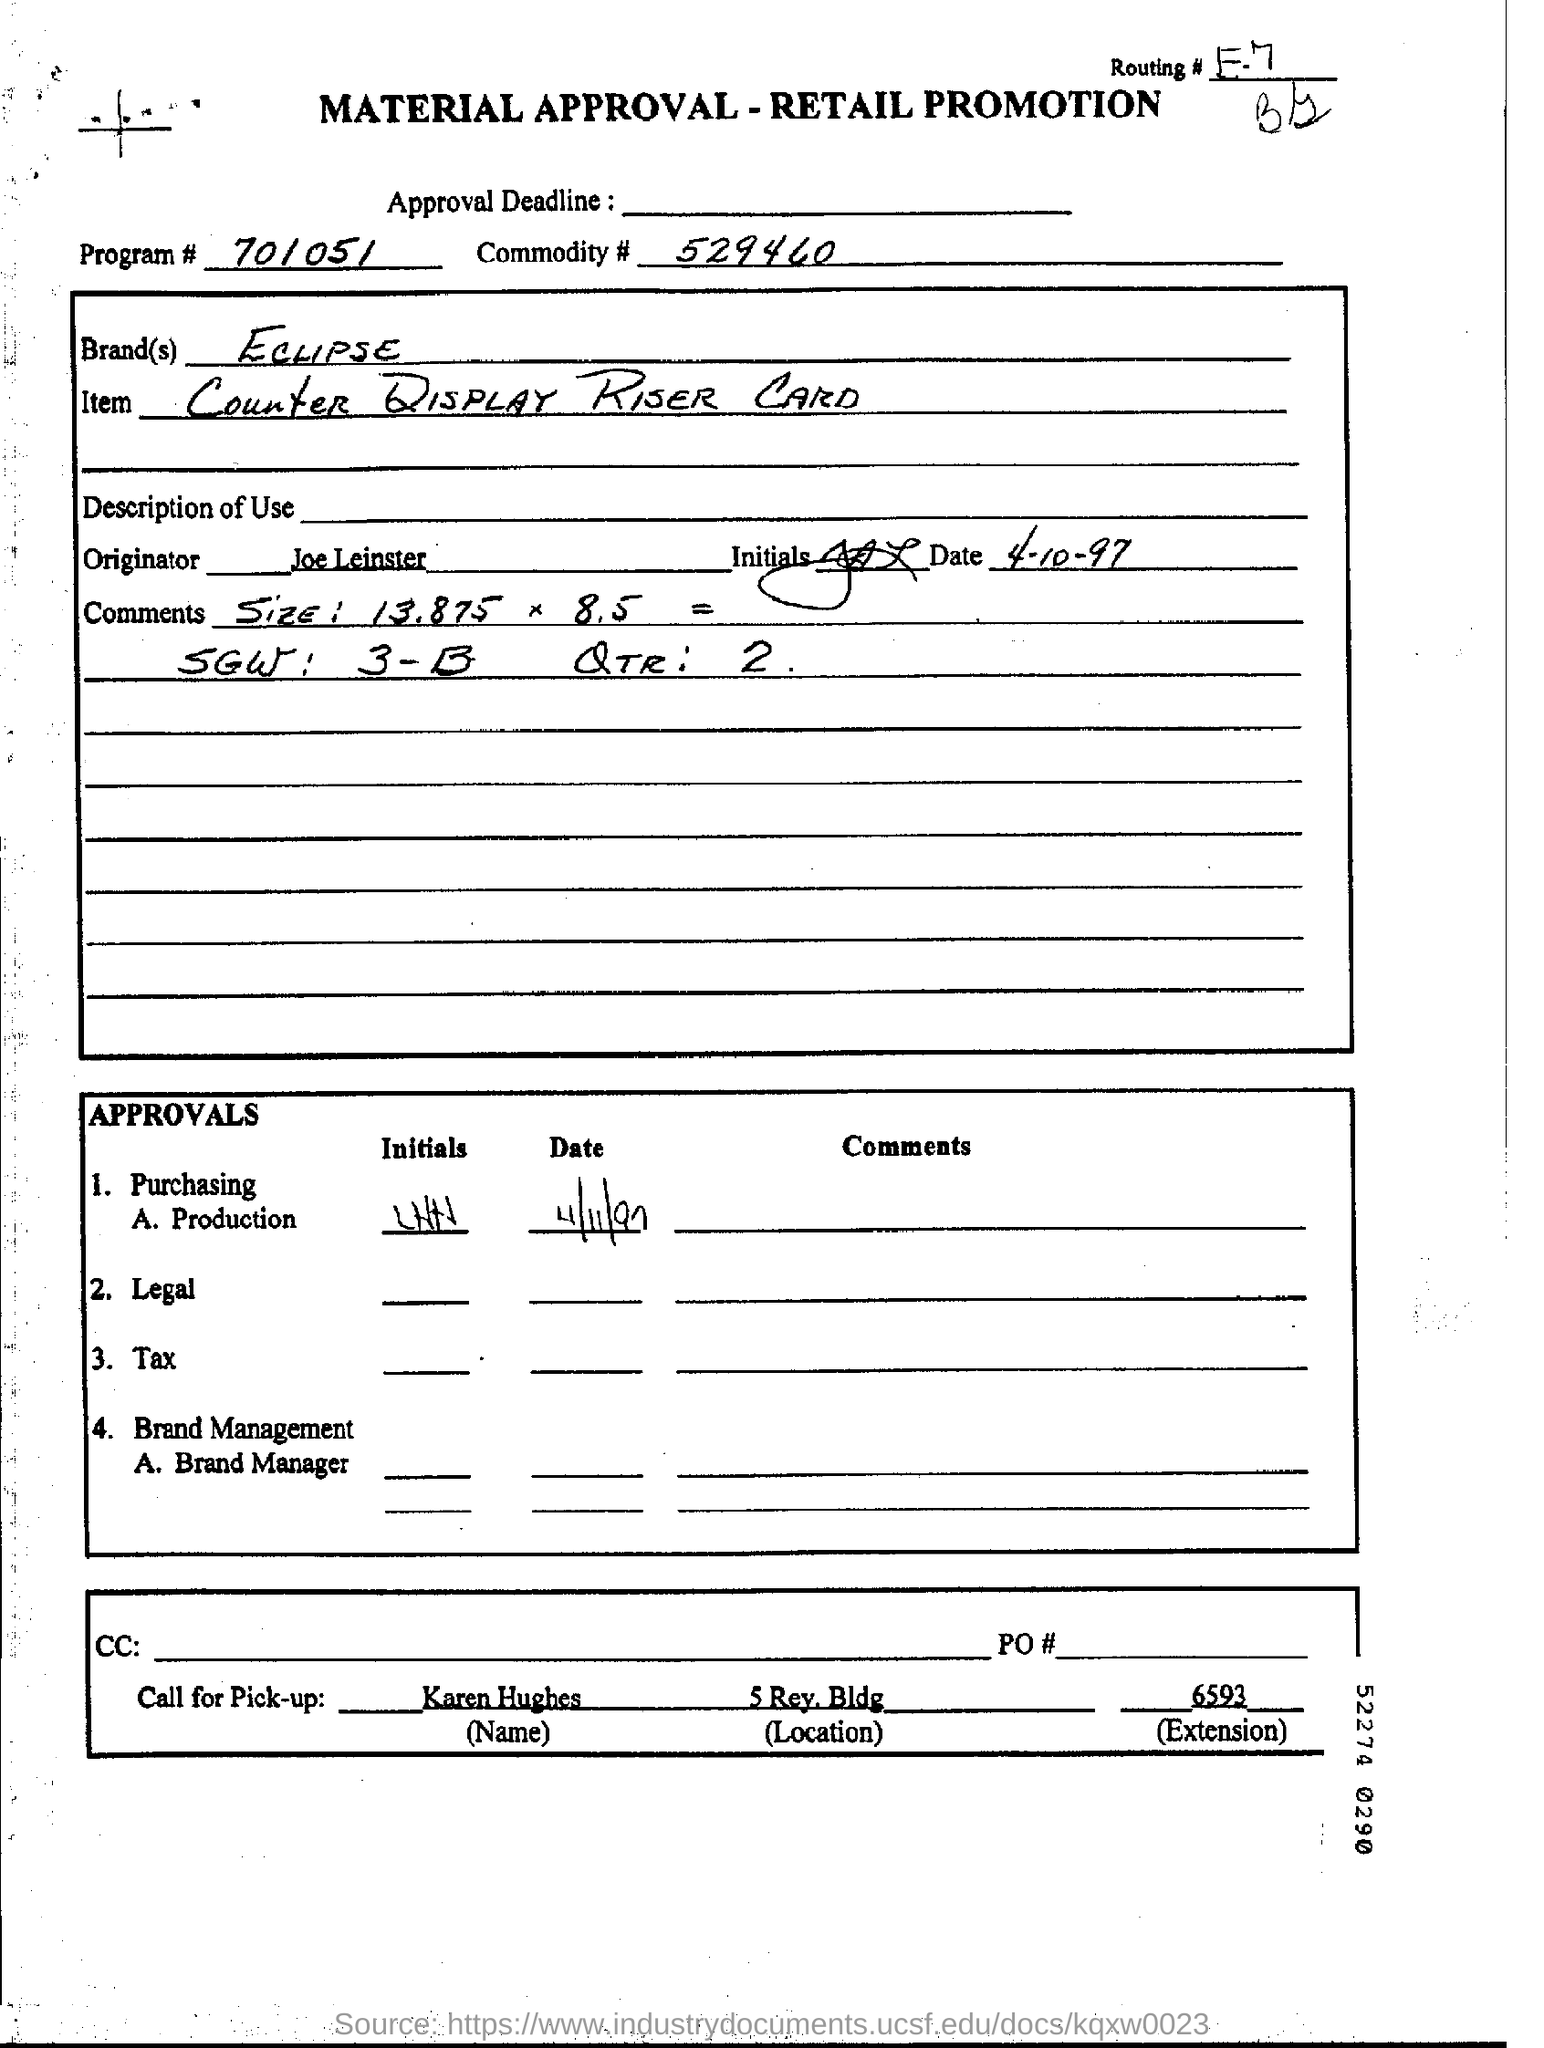Who is the originator?
Offer a very short reply. Joe Leinster. Whom to call for pick-up?
Your answer should be compact. Karen Hughes. 